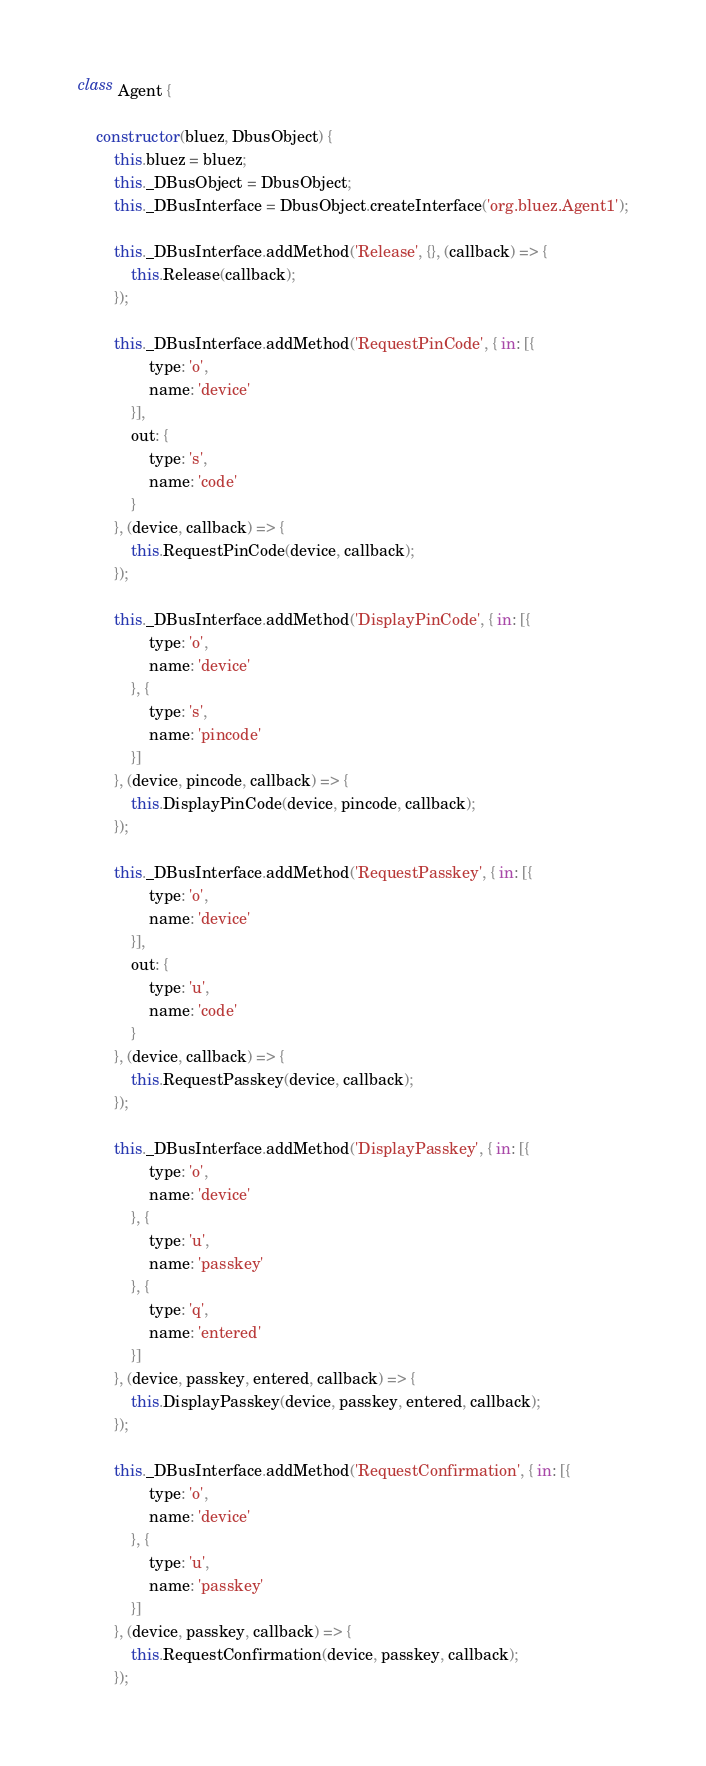Convert code to text. <code><loc_0><loc_0><loc_500><loc_500><_JavaScript_>class Agent {

    constructor(bluez, DbusObject) {
        this.bluez = bluez;
        this._DBusObject = DbusObject;
        this._DBusInterface = DbusObject.createInterface('org.bluez.Agent1');

        this._DBusInterface.addMethod('Release', {}, (callback) => {
            this.Release(callback);
        });

        this._DBusInterface.addMethod('RequestPinCode', { in: [{
                type: 'o',
                name: 'device'
            }],
            out: {
                type: 's',
                name: 'code'
            }
        }, (device, callback) => {
            this.RequestPinCode(device, callback);
        });

        this._DBusInterface.addMethod('DisplayPinCode', { in: [{
                type: 'o',
                name: 'device'
            }, {
                type: 's',
                name: 'pincode'
            }]
        }, (device, pincode, callback) => {
            this.DisplayPinCode(device, pincode, callback);
        });

        this._DBusInterface.addMethod('RequestPasskey', { in: [{
                type: 'o',
                name: 'device'
            }],
            out: {
                type: 'u',
                name: 'code'
            }
        }, (device, callback) => {
            this.RequestPasskey(device, callback);
        });

        this._DBusInterface.addMethod('DisplayPasskey', { in: [{
                type: 'o',
                name: 'device'
            }, {
                type: 'u',
                name: 'passkey'
            }, {
                type: 'q',
                name: 'entered'
            }]
        }, (device, passkey, entered, callback) => {
            this.DisplayPasskey(device, passkey, entered, callback);
        });

        this._DBusInterface.addMethod('RequestConfirmation', { in: [{
                type: 'o',
                name: 'device'
            }, {
                type: 'u',
                name: 'passkey'
            }]
        }, (device, passkey, callback) => {
            this.RequestConfirmation(device, passkey, callback);
        });
</code> 